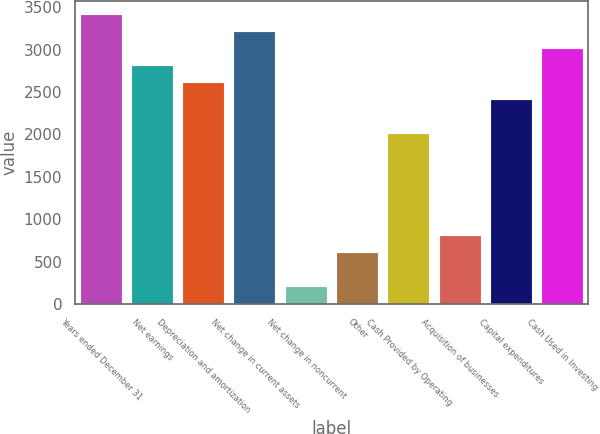Convert chart. <chart><loc_0><loc_0><loc_500><loc_500><bar_chart><fcel>Years ended December 31<fcel>Net earnings<fcel>Depreciation and amortization<fcel>Net change in current assets<fcel>Net change in noncurrent<fcel>Other<fcel>Cash Provided by Operating<fcel>Acquisition of businesses<fcel>Capital expenditures<fcel>Cash Used in Investing<nl><fcel>3405.03<fcel>2804.16<fcel>2603.87<fcel>3204.74<fcel>200.39<fcel>600.97<fcel>2003<fcel>801.26<fcel>2403.58<fcel>3004.45<nl></chart> 